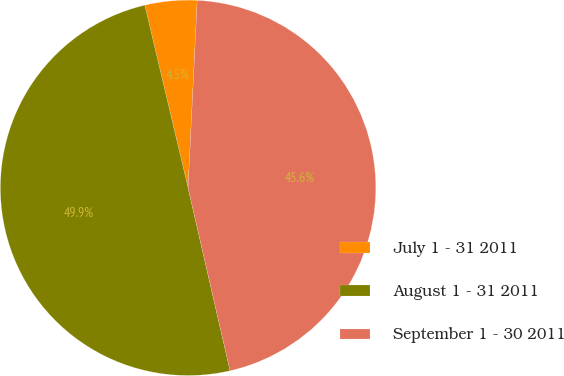Convert chart to OTSL. <chart><loc_0><loc_0><loc_500><loc_500><pie_chart><fcel>July 1 - 31 2011<fcel>August 1 - 31 2011<fcel>September 1 - 30 2011<nl><fcel>4.48%<fcel>49.89%<fcel>45.63%<nl></chart> 